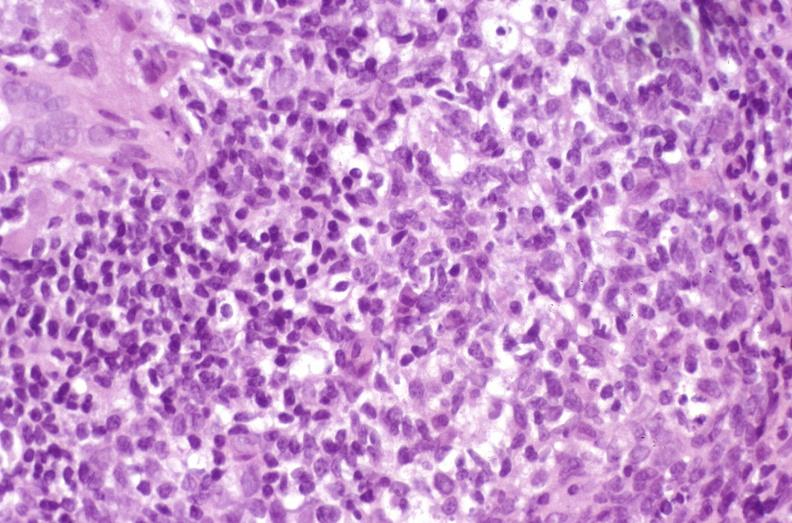does adenocarcinoma show recurrent hepatitis c virus?
Answer the question using a single word or phrase. No 